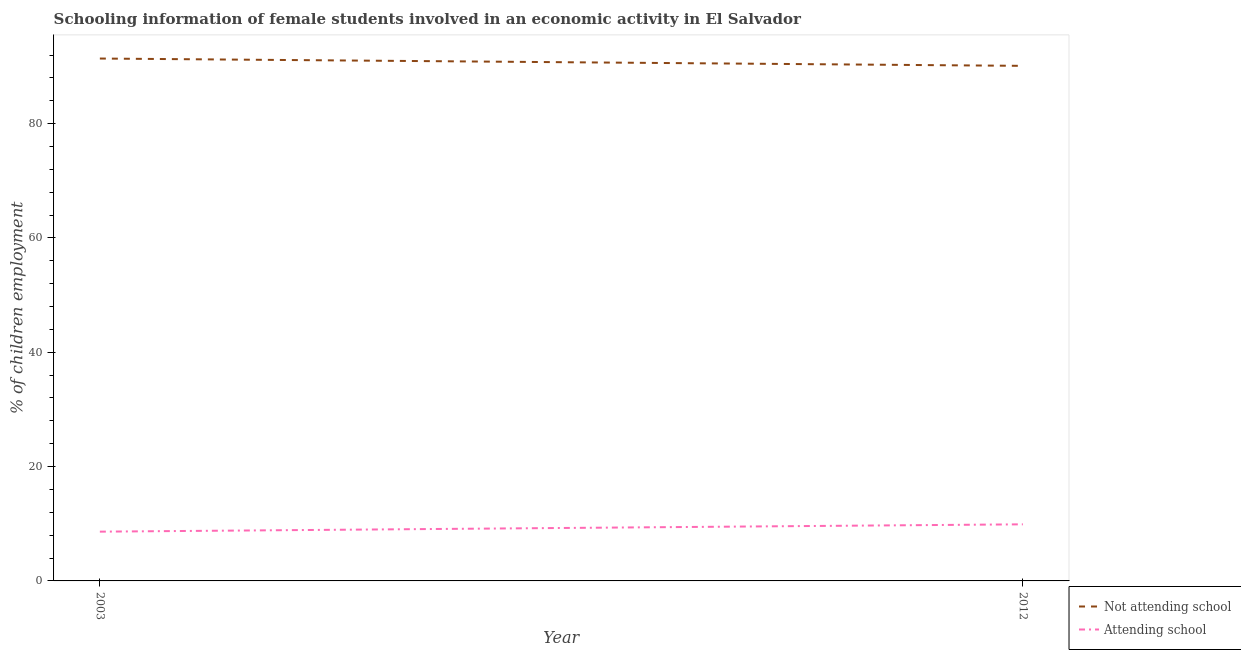How many different coloured lines are there?
Give a very brief answer. 2. Is the number of lines equal to the number of legend labels?
Provide a short and direct response. Yes. What is the percentage of employed females who are attending school in 2003?
Ensure brevity in your answer.  8.62. Across all years, what is the maximum percentage of employed females who are not attending school?
Offer a very short reply. 91.38. Across all years, what is the minimum percentage of employed females who are attending school?
Give a very brief answer. 8.62. In which year was the percentage of employed females who are not attending school maximum?
Your answer should be very brief. 2003. In which year was the percentage of employed females who are not attending school minimum?
Provide a succinct answer. 2012. What is the total percentage of employed females who are not attending school in the graph?
Offer a terse response. 181.48. What is the difference between the percentage of employed females who are attending school in 2003 and that in 2012?
Provide a short and direct response. -1.28. What is the difference between the percentage of employed females who are attending school in 2012 and the percentage of employed females who are not attending school in 2003?
Make the answer very short. -81.48. What is the average percentage of employed females who are attending school per year?
Provide a short and direct response. 9.26. In the year 2012, what is the difference between the percentage of employed females who are not attending school and percentage of employed females who are attending school?
Provide a succinct answer. 80.2. What is the ratio of the percentage of employed females who are attending school in 2003 to that in 2012?
Offer a terse response. 0.87. Is the percentage of employed females who are attending school in 2003 less than that in 2012?
Your answer should be compact. Yes. In how many years, is the percentage of employed females who are not attending school greater than the average percentage of employed females who are not attending school taken over all years?
Your response must be concise. 1. Does the percentage of employed females who are not attending school monotonically increase over the years?
Your answer should be compact. No. Is the percentage of employed females who are not attending school strictly greater than the percentage of employed females who are attending school over the years?
Ensure brevity in your answer.  Yes. Is the percentage of employed females who are not attending school strictly less than the percentage of employed females who are attending school over the years?
Your response must be concise. No. How many lines are there?
Ensure brevity in your answer.  2. What is the difference between two consecutive major ticks on the Y-axis?
Provide a succinct answer. 20. Where does the legend appear in the graph?
Give a very brief answer. Bottom right. How are the legend labels stacked?
Offer a terse response. Vertical. What is the title of the graph?
Your answer should be compact. Schooling information of female students involved in an economic activity in El Salvador. Does "Money lenders" appear as one of the legend labels in the graph?
Provide a succinct answer. No. What is the label or title of the X-axis?
Offer a very short reply. Year. What is the label or title of the Y-axis?
Give a very brief answer. % of children employment. What is the % of children employment in Not attending school in 2003?
Your response must be concise. 91.38. What is the % of children employment in Attending school in 2003?
Provide a short and direct response. 8.62. What is the % of children employment in Not attending school in 2012?
Keep it short and to the point. 90.1. Across all years, what is the maximum % of children employment of Not attending school?
Your answer should be very brief. 91.38. Across all years, what is the minimum % of children employment of Not attending school?
Offer a terse response. 90.1. Across all years, what is the minimum % of children employment in Attending school?
Ensure brevity in your answer.  8.62. What is the total % of children employment of Not attending school in the graph?
Offer a very short reply. 181.48. What is the total % of children employment in Attending school in the graph?
Make the answer very short. 18.52. What is the difference between the % of children employment in Not attending school in 2003 and that in 2012?
Your answer should be very brief. 1.28. What is the difference between the % of children employment of Attending school in 2003 and that in 2012?
Provide a succinct answer. -1.28. What is the difference between the % of children employment in Not attending school in 2003 and the % of children employment in Attending school in 2012?
Provide a short and direct response. 81.48. What is the average % of children employment in Not attending school per year?
Make the answer very short. 90.74. What is the average % of children employment in Attending school per year?
Keep it short and to the point. 9.26. In the year 2003, what is the difference between the % of children employment in Not attending school and % of children employment in Attending school?
Provide a succinct answer. 82.77. In the year 2012, what is the difference between the % of children employment in Not attending school and % of children employment in Attending school?
Keep it short and to the point. 80.2. What is the ratio of the % of children employment in Not attending school in 2003 to that in 2012?
Keep it short and to the point. 1.01. What is the ratio of the % of children employment in Attending school in 2003 to that in 2012?
Your answer should be very brief. 0.87. What is the difference between the highest and the second highest % of children employment in Not attending school?
Your answer should be compact. 1.28. What is the difference between the highest and the second highest % of children employment of Attending school?
Your answer should be compact. 1.28. What is the difference between the highest and the lowest % of children employment of Not attending school?
Keep it short and to the point. 1.28. What is the difference between the highest and the lowest % of children employment of Attending school?
Offer a terse response. 1.28. 